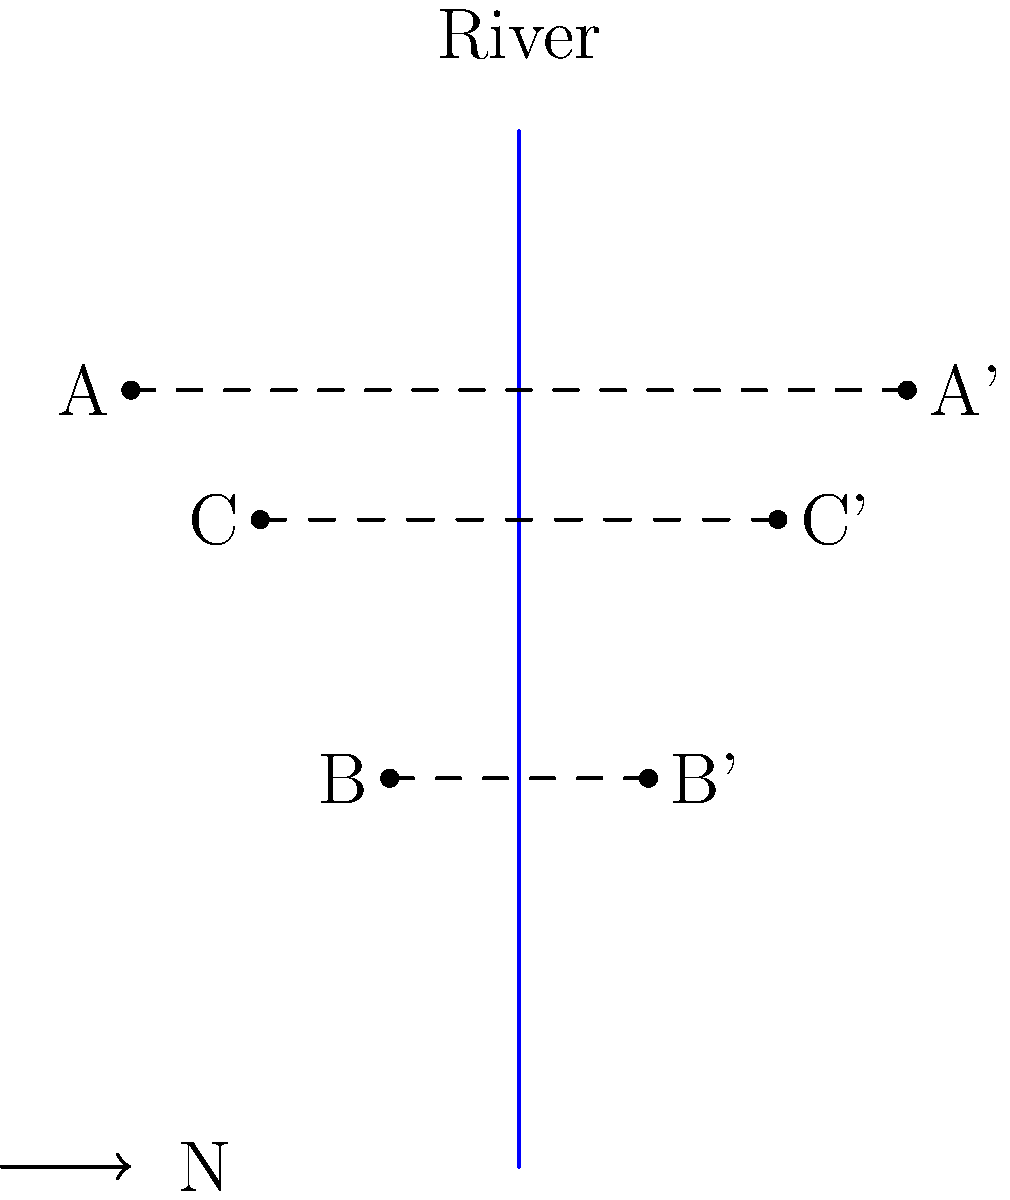You're planning a sightseeing tour along a river that runs directly north-south. Three landmarks (A, B, and C) are located on the west side of the river. To ensure tourists on the east side can also enjoy the views, you want to find mirror locations for these landmarks. If landmark A is reflected across the river to point A', what are the coordinates of A' given that A is located at (-1.5, 1)? To solve this problem, we need to understand the concept of reflection across a line. In this case, we're reflecting across the river, which acts as our line of reflection. The river runs north-south, which means it's parallel to the y-axis and can be represented by the equation x = 0.

Let's approach this step-by-step:

1) The general rule for reflecting a point (x, y) across the y-axis (x = 0) is to change the sign of the x-coordinate. The y-coordinate remains the same.

2) The coordinates of point A are given as (-1.5, 1).

3) To reflect this point:
   - The x-coordinate changes from -1.5 to 1.5 (the opposite of -1.5)
   - The y-coordinate remains 1

4) Therefore, the coordinates of A' will be (1.5, 1).

This reflection maintains the same distance from the river (our line of reflection) and preserves the y-coordinate, which is a key property of reflections.
Answer: (1.5, 1) 